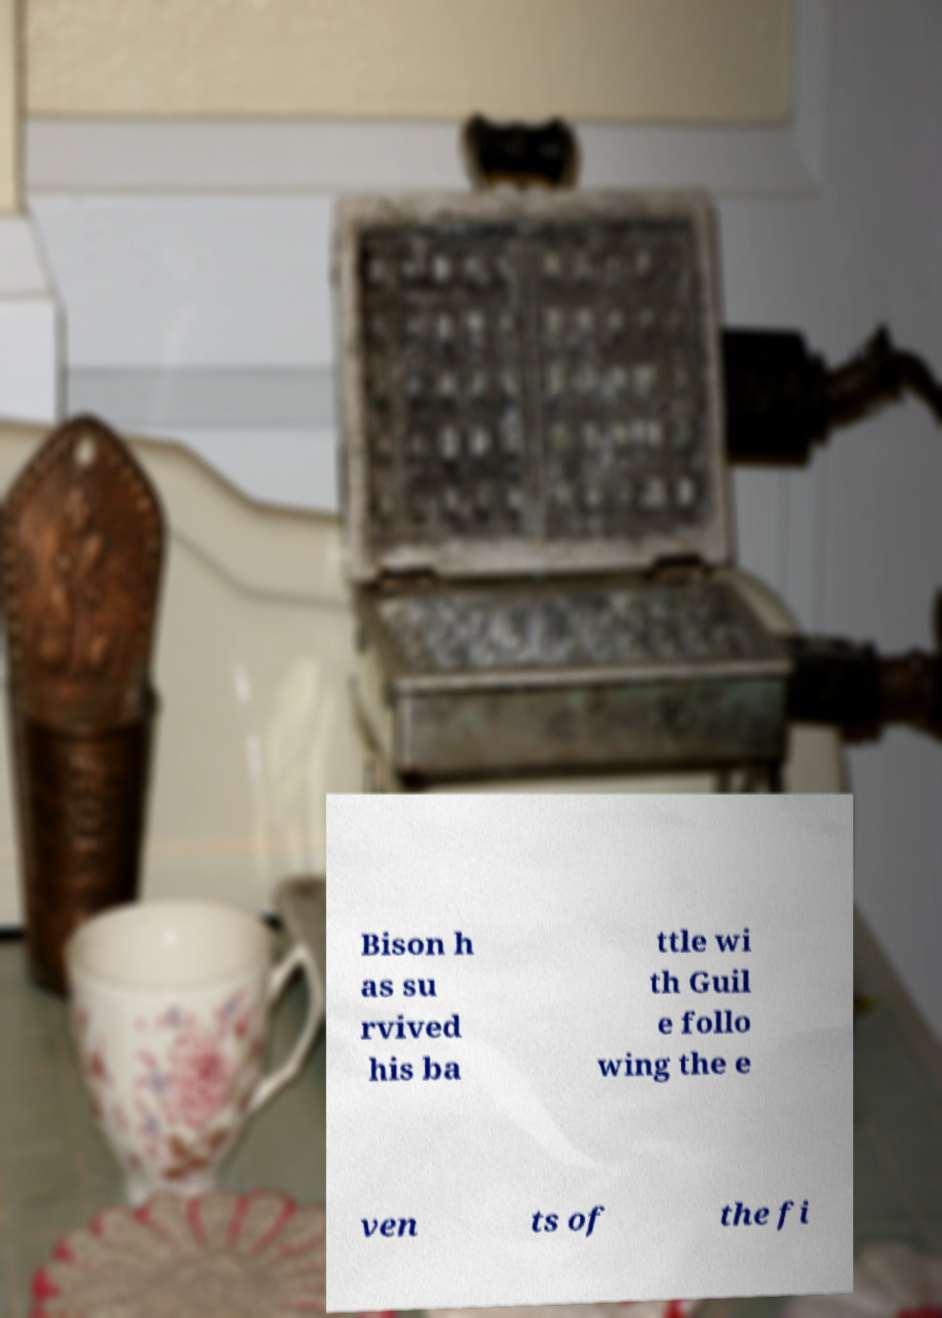Please read and relay the text visible in this image. What does it say? Bison h as su rvived his ba ttle wi th Guil e follo wing the e ven ts of the fi 